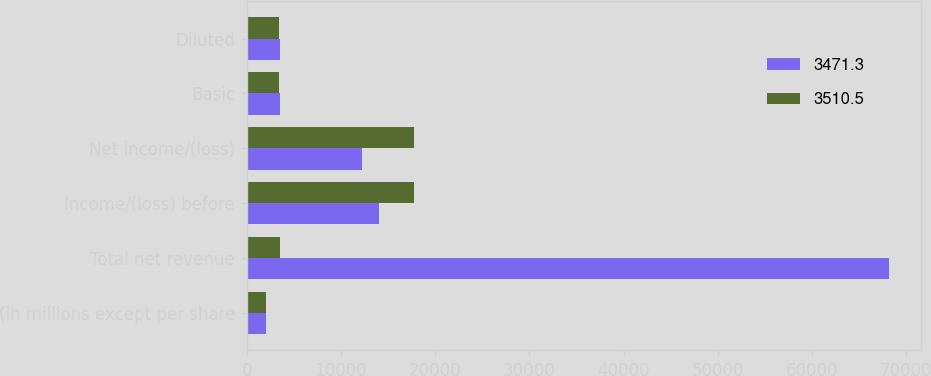<chart> <loc_0><loc_0><loc_500><loc_500><stacked_bar_chart><ecel><fcel>(in millions except per share<fcel>Total net revenue<fcel>Income/(loss) before<fcel>Net income/(loss)<fcel>Basic<fcel>Diluted<nl><fcel>3471.3<fcel>2008<fcel>68149<fcel>14090<fcel>12184<fcel>3510.5<fcel>3510.5<nl><fcel>3510.5<fcel>2007<fcel>3510.5<fcel>17733<fcel>17733<fcel>3429.6<fcel>3471.3<nl></chart> 